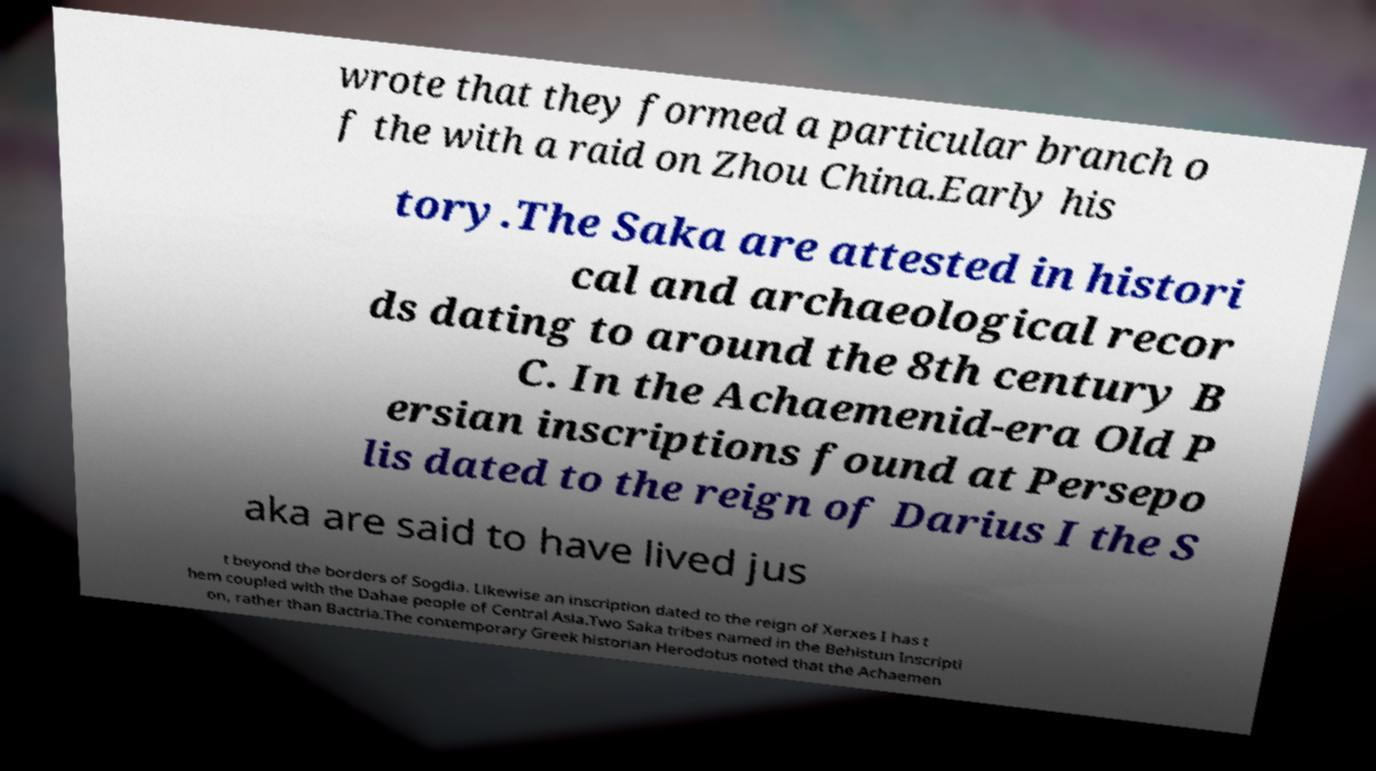Could you assist in decoding the text presented in this image and type it out clearly? wrote that they formed a particular branch o f the with a raid on Zhou China.Early his tory.The Saka are attested in histori cal and archaeological recor ds dating to around the 8th century B C. In the Achaemenid-era Old P ersian inscriptions found at Persepo lis dated to the reign of Darius I the S aka are said to have lived jus t beyond the borders of Sogdia. Likewise an inscription dated to the reign of Xerxes I has t hem coupled with the Dahae people of Central Asia.Two Saka tribes named in the Behistun Inscripti on, rather than Bactria.The contemporary Greek historian Herodotus noted that the Achaemen 